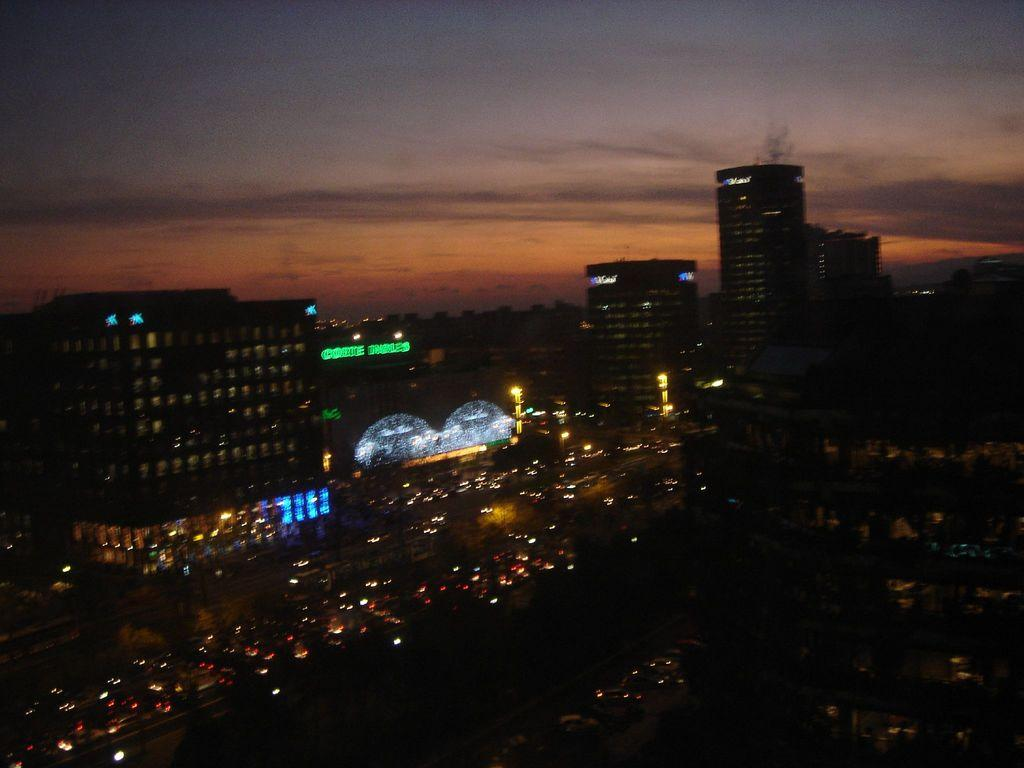What can be seen in the image in terms of structures? There are many buildings in the image. What else is visible on the ground in the image? There are vehicles parked on the road in the image. Can you describe the quality of the image? The image is slightly blurred. What is the appearance of the sky in the image? The sky appears dark in the image. Can you see anyone wearing a hat in the image? There is no hat visible in the image. How does the air in the image appear to be breathing? The concept of "breathing air" is not applicable to an image, as it is a static representation and does not involve the movement of air or any living beings. 